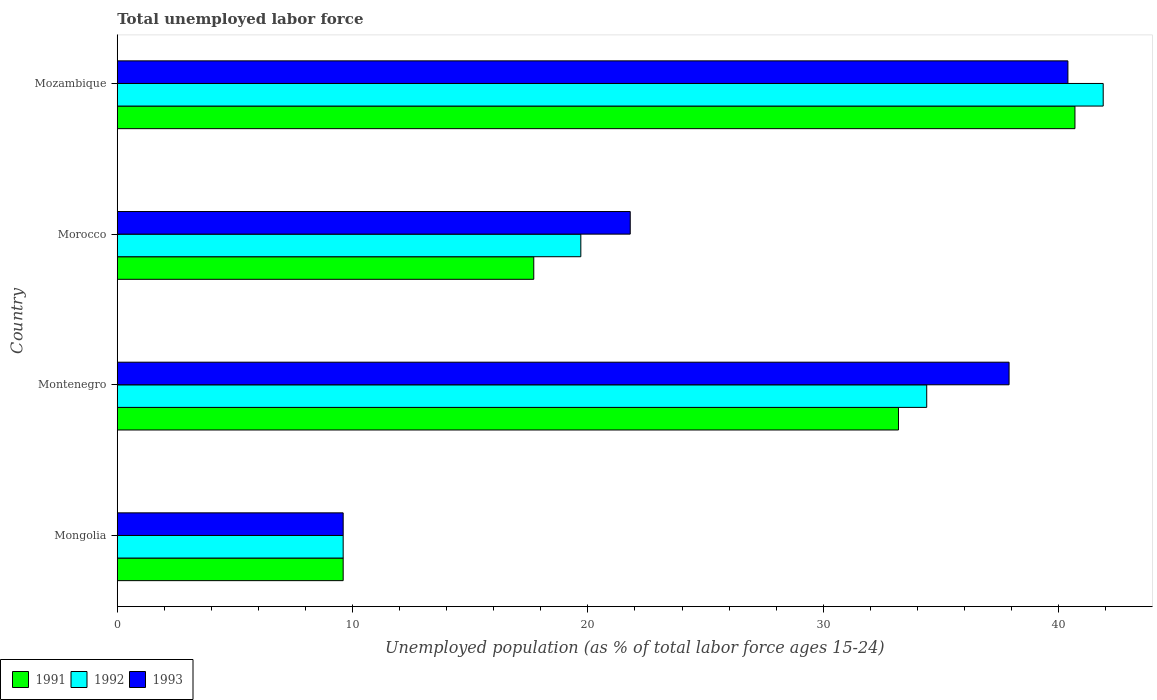How many bars are there on the 4th tick from the top?
Your answer should be compact. 3. How many bars are there on the 3rd tick from the bottom?
Keep it short and to the point. 3. What is the label of the 1st group of bars from the top?
Offer a terse response. Mozambique. In how many cases, is the number of bars for a given country not equal to the number of legend labels?
Provide a succinct answer. 0. What is the percentage of unemployed population in in 1993 in Mozambique?
Provide a short and direct response. 40.4. Across all countries, what is the maximum percentage of unemployed population in in 1992?
Keep it short and to the point. 41.9. Across all countries, what is the minimum percentage of unemployed population in in 1992?
Offer a very short reply. 9.6. In which country was the percentage of unemployed population in in 1993 maximum?
Provide a succinct answer. Mozambique. In which country was the percentage of unemployed population in in 1991 minimum?
Provide a succinct answer. Mongolia. What is the total percentage of unemployed population in in 1993 in the graph?
Provide a succinct answer. 109.7. What is the difference between the percentage of unemployed population in in 1993 in Mongolia and that in Mozambique?
Your answer should be very brief. -30.8. What is the difference between the percentage of unemployed population in in 1991 in Mongolia and the percentage of unemployed population in in 1993 in Morocco?
Offer a terse response. -12.2. What is the average percentage of unemployed population in in 1991 per country?
Provide a short and direct response. 25.3. What is the difference between the percentage of unemployed population in in 1991 and percentage of unemployed population in in 1992 in Morocco?
Make the answer very short. -2. In how many countries, is the percentage of unemployed population in in 1993 greater than 26 %?
Provide a short and direct response. 2. What is the ratio of the percentage of unemployed population in in 1992 in Mongolia to that in Mozambique?
Give a very brief answer. 0.23. Is the percentage of unemployed population in in 1992 in Mongolia less than that in Morocco?
Keep it short and to the point. Yes. Is the difference between the percentage of unemployed population in in 1991 in Montenegro and Morocco greater than the difference between the percentage of unemployed population in in 1992 in Montenegro and Morocco?
Make the answer very short. Yes. What is the difference between the highest and the lowest percentage of unemployed population in in 1993?
Provide a succinct answer. 30.8. In how many countries, is the percentage of unemployed population in in 1993 greater than the average percentage of unemployed population in in 1993 taken over all countries?
Keep it short and to the point. 2. Are all the bars in the graph horizontal?
Ensure brevity in your answer.  Yes. Does the graph contain any zero values?
Ensure brevity in your answer.  No. How many legend labels are there?
Offer a very short reply. 3. How are the legend labels stacked?
Your response must be concise. Horizontal. What is the title of the graph?
Offer a terse response. Total unemployed labor force. What is the label or title of the X-axis?
Ensure brevity in your answer.  Unemployed population (as % of total labor force ages 15-24). What is the label or title of the Y-axis?
Your answer should be very brief. Country. What is the Unemployed population (as % of total labor force ages 15-24) in 1991 in Mongolia?
Make the answer very short. 9.6. What is the Unemployed population (as % of total labor force ages 15-24) in 1992 in Mongolia?
Your answer should be very brief. 9.6. What is the Unemployed population (as % of total labor force ages 15-24) of 1993 in Mongolia?
Your answer should be compact. 9.6. What is the Unemployed population (as % of total labor force ages 15-24) of 1991 in Montenegro?
Offer a very short reply. 33.2. What is the Unemployed population (as % of total labor force ages 15-24) of 1992 in Montenegro?
Offer a very short reply. 34.4. What is the Unemployed population (as % of total labor force ages 15-24) in 1993 in Montenegro?
Offer a terse response. 37.9. What is the Unemployed population (as % of total labor force ages 15-24) in 1991 in Morocco?
Keep it short and to the point. 17.7. What is the Unemployed population (as % of total labor force ages 15-24) of 1992 in Morocco?
Your answer should be compact. 19.7. What is the Unemployed population (as % of total labor force ages 15-24) in 1993 in Morocco?
Keep it short and to the point. 21.8. What is the Unemployed population (as % of total labor force ages 15-24) in 1991 in Mozambique?
Offer a terse response. 40.7. What is the Unemployed population (as % of total labor force ages 15-24) of 1992 in Mozambique?
Make the answer very short. 41.9. What is the Unemployed population (as % of total labor force ages 15-24) of 1993 in Mozambique?
Offer a very short reply. 40.4. Across all countries, what is the maximum Unemployed population (as % of total labor force ages 15-24) in 1991?
Give a very brief answer. 40.7. Across all countries, what is the maximum Unemployed population (as % of total labor force ages 15-24) of 1992?
Your response must be concise. 41.9. Across all countries, what is the maximum Unemployed population (as % of total labor force ages 15-24) in 1993?
Ensure brevity in your answer.  40.4. Across all countries, what is the minimum Unemployed population (as % of total labor force ages 15-24) of 1991?
Make the answer very short. 9.6. Across all countries, what is the minimum Unemployed population (as % of total labor force ages 15-24) of 1992?
Your answer should be very brief. 9.6. Across all countries, what is the minimum Unemployed population (as % of total labor force ages 15-24) in 1993?
Your response must be concise. 9.6. What is the total Unemployed population (as % of total labor force ages 15-24) in 1991 in the graph?
Offer a terse response. 101.2. What is the total Unemployed population (as % of total labor force ages 15-24) of 1992 in the graph?
Your response must be concise. 105.6. What is the total Unemployed population (as % of total labor force ages 15-24) of 1993 in the graph?
Your response must be concise. 109.7. What is the difference between the Unemployed population (as % of total labor force ages 15-24) in 1991 in Mongolia and that in Montenegro?
Your answer should be very brief. -23.6. What is the difference between the Unemployed population (as % of total labor force ages 15-24) of 1992 in Mongolia and that in Montenegro?
Your answer should be compact. -24.8. What is the difference between the Unemployed population (as % of total labor force ages 15-24) in 1993 in Mongolia and that in Montenegro?
Provide a succinct answer. -28.3. What is the difference between the Unemployed population (as % of total labor force ages 15-24) in 1992 in Mongolia and that in Morocco?
Keep it short and to the point. -10.1. What is the difference between the Unemployed population (as % of total labor force ages 15-24) in 1993 in Mongolia and that in Morocco?
Your answer should be very brief. -12.2. What is the difference between the Unemployed population (as % of total labor force ages 15-24) in 1991 in Mongolia and that in Mozambique?
Provide a succinct answer. -31.1. What is the difference between the Unemployed population (as % of total labor force ages 15-24) of 1992 in Mongolia and that in Mozambique?
Keep it short and to the point. -32.3. What is the difference between the Unemployed population (as % of total labor force ages 15-24) of 1993 in Mongolia and that in Mozambique?
Provide a succinct answer. -30.8. What is the difference between the Unemployed population (as % of total labor force ages 15-24) of 1993 in Montenegro and that in Morocco?
Your answer should be compact. 16.1. What is the difference between the Unemployed population (as % of total labor force ages 15-24) of 1992 in Montenegro and that in Mozambique?
Make the answer very short. -7.5. What is the difference between the Unemployed population (as % of total labor force ages 15-24) of 1993 in Montenegro and that in Mozambique?
Your answer should be compact. -2.5. What is the difference between the Unemployed population (as % of total labor force ages 15-24) of 1992 in Morocco and that in Mozambique?
Offer a very short reply. -22.2. What is the difference between the Unemployed population (as % of total labor force ages 15-24) of 1993 in Morocco and that in Mozambique?
Your answer should be very brief. -18.6. What is the difference between the Unemployed population (as % of total labor force ages 15-24) in 1991 in Mongolia and the Unemployed population (as % of total labor force ages 15-24) in 1992 in Montenegro?
Keep it short and to the point. -24.8. What is the difference between the Unemployed population (as % of total labor force ages 15-24) of 1991 in Mongolia and the Unemployed population (as % of total labor force ages 15-24) of 1993 in Montenegro?
Your response must be concise. -28.3. What is the difference between the Unemployed population (as % of total labor force ages 15-24) in 1992 in Mongolia and the Unemployed population (as % of total labor force ages 15-24) in 1993 in Montenegro?
Offer a terse response. -28.3. What is the difference between the Unemployed population (as % of total labor force ages 15-24) in 1991 in Mongolia and the Unemployed population (as % of total labor force ages 15-24) in 1993 in Morocco?
Provide a short and direct response. -12.2. What is the difference between the Unemployed population (as % of total labor force ages 15-24) of 1992 in Mongolia and the Unemployed population (as % of total labor force ages 15-24) of 1993 in Morocco?
Provide a short and direct response. -12.2. What is the difference between the Unemployed population (as % of total labor force ages 15-24) in 1991 in Mongolia and the Unemployed population (as % of total labor force ages 15-24) in 1992 in Mozambique?
Provide a succinct answer. -32.3. What is the difference between the Unemployed population (as % of total labor force ages 15-24) in 1991 in Mongolia and the Unemployed population (as % of total labor force ages 15-24) in 1993 in Mozambique?
Provide a short and direct response. -30.8. What is the difference between the Unemployed population (as % of total labor force ages 15-24) of 1992 in Mongolia and the Unemployed population (as % of total labor force ages 15-24) of 1993 in Mozambique?
Offer a very short reply. -30.8. What is the difference between the Unemployed population (as % of total labor force ages 15-24) in 1991 in Montenegro and the Unemployed population (as % of total labor force ages 15-24) in 1993 in Morocco?
Ensure brevity in your answer.  11.4. What is the difference between the Unemployed population (as % of total labor force ages 15-24) of 1991 in Montenegro and the Unemployed population (as % of total labor force ages 15-24) of 1993 in Mozambique?
Provide a short and direct response. -7.2. What is the difference between the Unemployed population (as % of total labor force ages 15-24) of 1991 in Morocco and the Unemployed population (as % of total labor force ages 15-24) of 1992 in Mozambique?
Ensure brevity in your answer.  -24.2. What is the difference between the Unemployed population (as % of total labor force ages 15-24) in 1991 in Morocco and the Unemployed population (as % of total labor force ages 15-24) in 1993 in Mozambique?
Make the answer very short. -22.7. What is the difference between the Unemployed population (as % of total labor force ages 15-24) of 1992 in Morocco and the Unemployed population (as % of total labor force ages 15-24) of 1993 in Mozambique?
Keep it short and to the point. -20.7. What is the average Unemployed population (as % of total labor force ages 15-24) of 1991 per country?
Your answer should be compact. 25.3. What is the average Unemployed population (as % of total labor force ages 15-24) in 1992 per country?
Give a very brief answer. 26.4. What is the average Unemployed population (as % of total labor force ages 15-24) of 1993 per country?
Keep it short and to the point. 27.43. What is the difference between the Unemployed population (as % of total labor force ages 15-24) in 1991 and Unemployed population (as % of total labor force ages 15-24) in 1992 in Montenegro?
Offer a terse response. -1.2. What is the difference between the Unemployed population (as % of total labor force ages 15-24) of 1991 and Unemployed population (as % of total labor force ages 15-24) of 1992 in Morocco?
Give a very brief answer. -2. What is the difference between the Unemployed population (as % of total labor force ages 15-24) in 1991 and Unemployed population (as % of total labor force ages 15-24) in 1992 in Mozambique?
Keep it short and to the point. -1.2. What is the ratio of the Unemployed population (as % of total labor force ages 15-24) in 1991 in Mongolia to that in Montenegro?
Your answer should be very brief. 0.29. What is the ratio of the Unemployed population (as % of total labor force ages 15-24) in 1992 in Mongolia to that in Montenegro?
Make the answer very short. 0.28. What is the ratio of the Unemployed population (as % of total labor force ages 15-24) of 1993 in Mongolia to that in Montenegro?
Your answer should be very brief. 0.25. What is the ratio of the Unemployed population (as % of total labor force ages 15-24) in 1991 in Mongolia to that in Morocco?
Offer a very short reply. 0.54. What is the ratio of the Unemployed population (as % of total labor force ages 15-24) in 1992 in Mongolia to that in Morocco?
Your response must be concise. 0.49. What is the ratio of the Unemployed population (as % of total labor force ages 15-24) in 1993 in Mongolia to that in Morocco?
Give a very brief answer. 0.44. What is the ratio of the Unemployed population (as % of total labor force ages 15-24) in 1991 in Mongolia to that in Mozambique?
Give a very brief answer. 0.24. What is the ratio of the Unemployed population (as % of total labor force ages 15-24) of 1992 in Mongolia to that in Mozambique?
Give a very brief answer. 0.23. What is the ratio of the Unemployed population (as % of total labor force ages 15-24) in 1993 in Mongolia to that in Mozambique?
Offer a very short reply. 0.24. What is the ratio of the Unemployed population (as % of total labor force ages 15-24) of 1991 in Montenegro to that in Morocco?
Your answer should be compact. 1.88. What is the ratio of the Unemployed population (as % of total labor force ages 15-24) of 1992 in Montenegro to that in Morocco?
Offer a very short reply. 1.75. What is the ratio of the Unemployed population (as % of total labor force ages 15-24) of 1993 in Montenegro to that in Morocco?
Offer a terse response. 1.74. What is the ratio of the Unemployed population (as % of total labor force ages 15-24) in 1991 in Montenegro to that in Mozambique?
Offer a terse response. 0.82. What is the ratio of the Unemployed population (as % of total labor force ages 15-24) of 1992 in Montenegro to that in Mozambique?
Keep it short and to the point. 0.82. What is the ratio of the Unemployed population (as % of total labor force ages 15-24) of 1993 in Montenegro to that in Mozambique?
Provide a short and direct response. 0.94. What is the ratio of the Unemployed population (as % of total labor force ages 15-24) in 1991 in Morocco to that in Mozambique?
Your response must be concise. 0.43. What is the ratio of the Unemployed population (as % of total labor force ages 15-24) of 1992 in Morocco to that in Mozambique?
Provide a short and direct response. 0.47. What is the ratio of the Unemployed population (as % of total labor force ages 15-24) of 1993 in Morocco to that in Mozambique?
Provide a short and direct response. 0.54. What is the difference between the highest and the second highest Unemployed population (as % of total labor force ages 15-24) of 1991?
Your answer should be compact. 7.5. What is the difference between the highest and the second highest Unemployed population (as % of total labor force ages 15-24) of 1993?
Offer a very short reply. 2.5. What is the difference between the highest and the lowest Unemployed population (as % of total labor force ages 15-24) in 1991?
Ensure brevity in your answer.  31.1. What is the difference between the highest and the lowest Unemployed population (as % of total labor force ages 15-24) of 1992?
Give a very brief answer. 32.3. What is the difference between the highest and the lowest Unemployed population (as % of total labor force ages 15-24) of 1993?
Your answer should be compact. 30.8. 